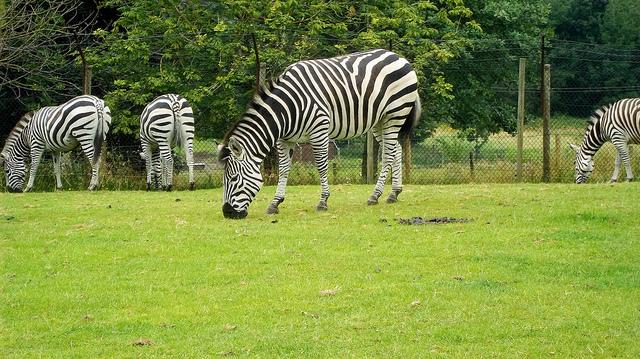Is the grassy field flat?
Concise answer only. Yes. What color are the zebra's stripes?
Write a very short answer. Black and white. Are there trees in the background?
Concise answer only. Yes. What is the zebra eating?
Keep it brief. Grass. How many zebras are in the picture?
Quick response, please. 4. 